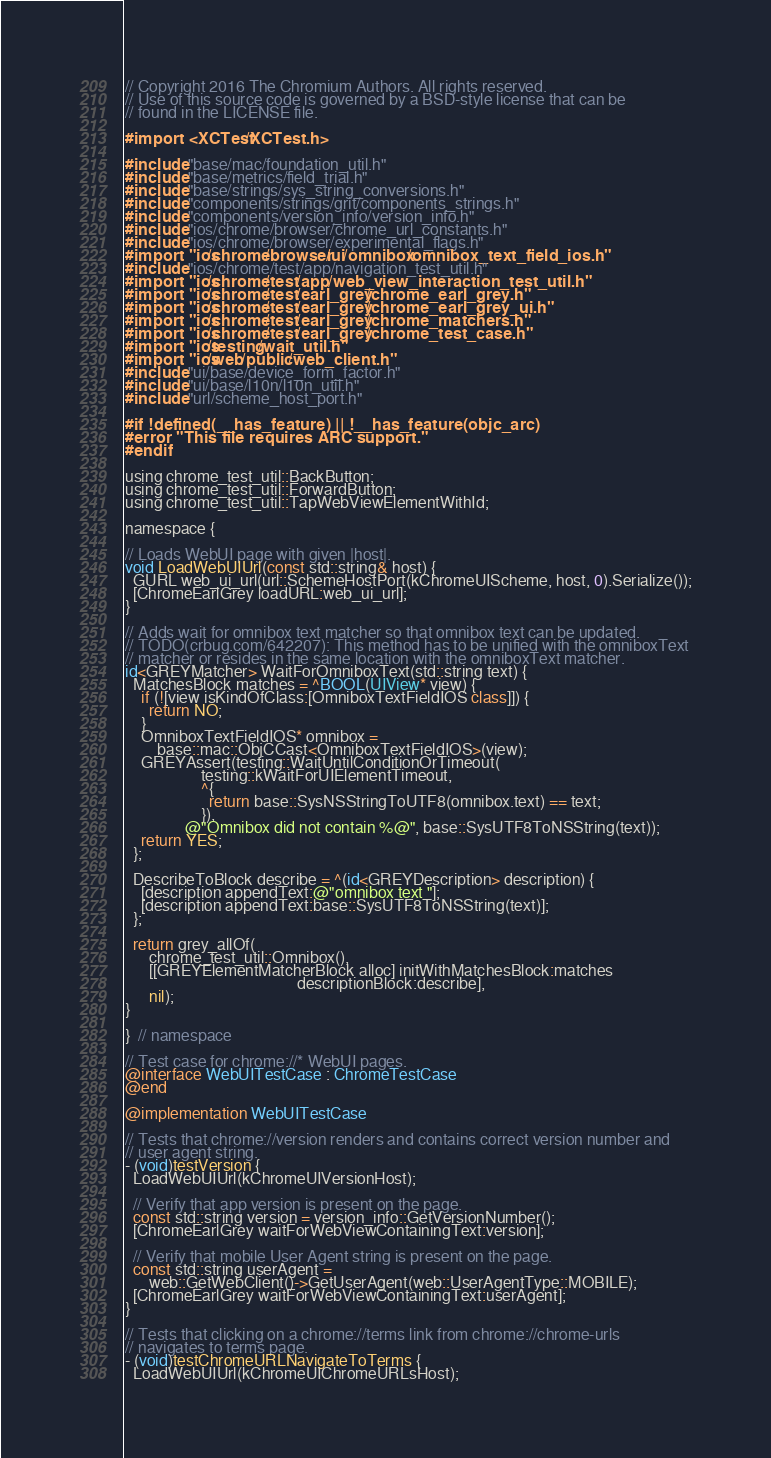<code> <loc_0><loc_0><loc_500><loc_500><_ObjectiveC_>// Copyright 2016 The Chromium Authors. All rights reserved.
// Use of this source code is governed by a BSD-style license that can be
// found in the LICENSE file.

#import <XCTest/XCTest.h>

#include "base/mac/foundation_util.h"
#include "base/metrics/field_trial.h"
#include "base/strings/sys_string_conversions.h"
#include "components/strings/grit/components_strings.h"
#include "components/version_info/version_info.h"
#include "ios/chrome/browser/chrome_url_constants.h"
#include "ios/chrome/browser/experimental_flags.h"
#import "ios/chrome/browser/ui/omnibox/omnibox_text_field_ios.h"
#include "ios/chrome/test/app/navigation_test_util.h"
#import "ios/chrome/test/app/web_view_interaction_test_util.h"
#import "ios/chrome/test/earl_grey/chrome_earl_grey.h"
#import "ios/chrome/test/earl_grey/chrome_earl_grey_ui.h"
#import "ios/chrome/test/earl_grey/chrome_matchers.h"
#import "ios/chrome/test/earl_grey/chrome_test_case.h"
#import "ios/testing/wait_util.h"
#import "ios/web/public/web_client.h"
#include "ui/base/device_form_factor.h"
#include "ui/base/l10n/l10n_util.h"
#include "url/scheme_host_port.h"

#if !defined(__has_feature) || !__has_feature(objc_arc)
#error "This file requires ARC support."
#endif

using chrome_test_util::BackButton;
using chrome_test_util::ForwardButton;
using chrome_test_util::TapWebViewElementWithId;

namespace {

// Loads WebUI page with given |host|.
void LoadWebUIUrl(const std::string& host) {
  GURL web_ui_url(url::SchemeHostPort(kChromeUIScheme, host, 0).Serialize());
  [ChromeEarlGrey loadURL:web_ui_url];
}

// Adds wait for omnibox text matcher so that omnibox text can be updated.
// TODO(crbug.com/642207): This method has to be unified with the omniboxText
// matcher or resides in the same location with the omniboxText matcher.
id<GREYMatcher> WaitForOmniboxText(std::string text) {
  MatchesBlock matches = ^BOOL(UIView* view) {
    if (![view isKindOfClass:[OmniboxTextFieldIOS class]]) {
      return NO;
    }
    OmniboxTextFieldIOS* omnibox =
        base::mac::ObjCCast<OmniboxTextFieldIOS>(view);
    GREYAssert(testing::WaitUntilConditionOrTimeout(
                   testing::kWaitForUIElementTimeout,
                   ^{
                     return base::SysNSStringToUTF8(omnibox.text) == text;
                   }),
               @"Omnibox did not contain %@", base::SysUTF8ToNSString(text));
    return YES;
  };

  DescribeToBlock describe = ^(id<GREYDescription> description) {
    [description appendText:@"omnibox text "];
    [description appendText:base::SysUTF8ToNSString(text)];
  };

  return grey_allOf(
      chrome_test_util::Omnibox(),
      [[GREYElementMatcherBlock alloc] initWithMatchesBlock:matches
                                           descriptionBlock:describe],
      nil);
}

}  // namespace

// Test case for chrome://* WebUI pages.
@interface WebUITestCase : ChromeTestCase
@end

@implementation WebUITestCase

// Tests that chrome://version renders and contains correct version number and
// user agent string.
- (void)testVersion {
  LoadWebUIUrl(kChromeUIVersionHost);

  // Verify that app version is present on the page.
  const std::string version = version_info::GetVersionNumber();
  [ChromeEarlGrey waitForWebViewContainingText:version];

  // Verify that mobile User Agent string is present on the page.
  const std::string userAgent =
      web::GetWebClient()->GetUserAgent(web::UserAgentType::MOBILE);
  [ChromeEarlGrey waitForWebViewContainingText:userAgent];
}

// Tests that clicking on a chrome://terms link from chrome://chrome-urls
// navigates to terms page.
- (void)testChromeURLNavigateToTerms {
  LoadWebUIUrl(kChromeUIChromeURLsHost);
</code> 